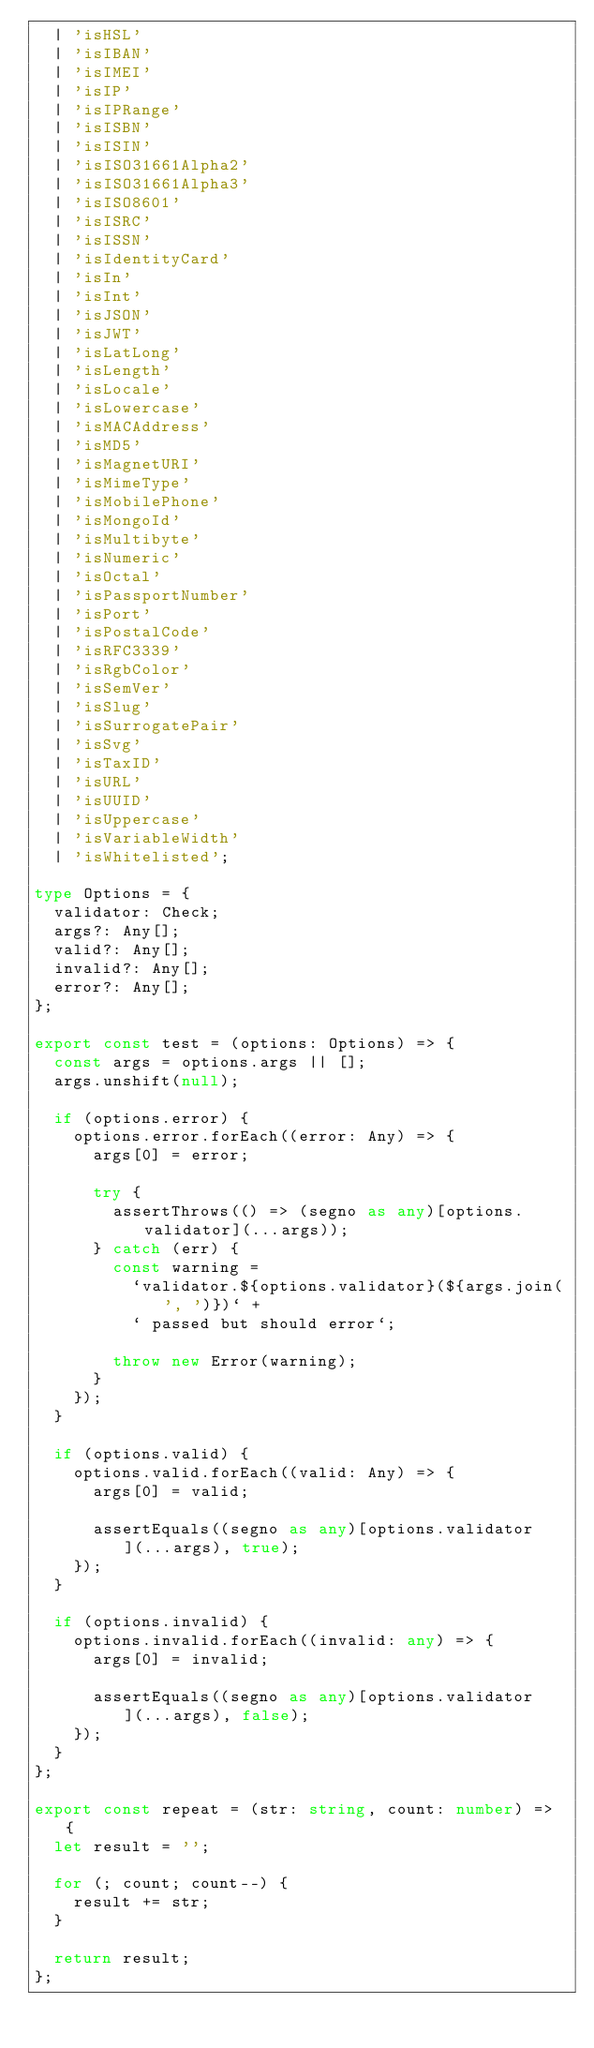Convert code to text. <code><loc_0><loc_0><loc_500><loc_500><_TypeScript_>  | 'isHSL'
  | 'isIBAN'
  | 'isIMEI'
  | 'isIP'
  | 'isIPRange'
  | 'isISBN'
  | 'isISIN'
  | 'isISO31661Alpha2'
  | 'isISO31661Alpha3'
  | 'isISO8601'
  | 'isISRC'
  | 'isISSN'
  | 'isIdentityCard'
  | 'isIn'
  | 'isInt'
  | 'isJSON'
  | 'isJWT'
  | 'isLatLong'
  | 'isLength'
  | 'isLocale'
  | 'isLowercase'
  | 'isMACAddress'
  | 'isMD5'
  | 'isMagnetURI'
  | 'isMimeType'
  | 'isMobilePhone'
  | 'isMongoId'
  | 'isMultibyte'
  | 'isNumeric'
  | 'isOctal'
  | 'isPassportNumber'
  | 'isPort'
  | 'isPostalCode'
  | 'isRFC3339'
  | 'isRgbColor'
  | 'isSemVer'
  | 'isSlug'
  | 'isSurrogatePair'
  | 'isSvg'
  | 'isTaxID'
  | 'isURL'
  | 'isUUID'
  | 'isUppercase'
  | 'isVariableWidth'
  | 'isWhitelisted';

type Options = {
  validator: Check;
  args?: Any[];
  valid?: Any[];
  invalid?: Any[];
  error?: Any[];
};

export const test = (options: Options) => {
  const args = options.args || [];
  args.unshift(null);

  if (options.error) {
    options.error.forEach((error: Any) => {
      args[0] = error;

      try {
        assertThrows(() => (segno as any)[options.validator](...args));
      } catch (err) {
        const warning =
          `validator.${options.validator}(${args.join(', ')})` +
          ` passed but should error`;

        throw new Error(warning);
      }
    });
  }

  if (options.valid) {
    options.valid.forEach((valid: Any) => {
      args[0] = valid;

      assertEquals((segno as any)[options.validator](...args), true);
    });
  }

  if (options.invalid) {
    options.invalid.forEach((invalid: any) => {
      args[0] = invalid;

      assertEquals((segno as any)[options.validator](...args), false);
    });
  }
};

export const repeat = (str: string, count: number) => {
  let result = '';

  for (; count; count--) {
    result += str;
  }

  return result;
};
</code> 